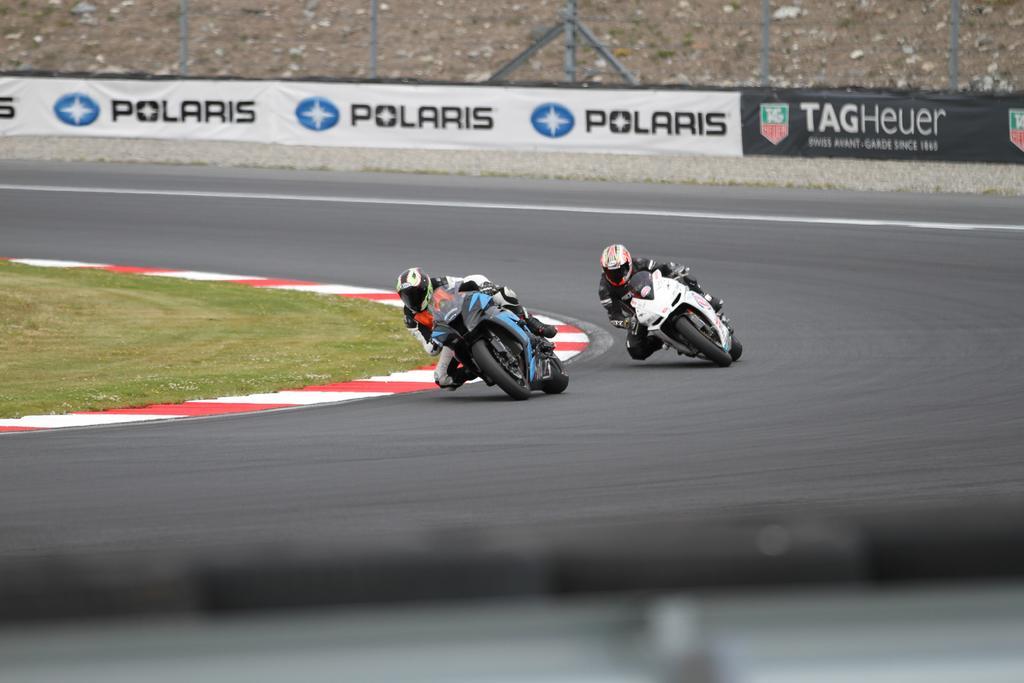Can you describe this image briefly? 2 persons are riding a bike and are racing with each other. Beside this person there is a grass. This 2 persons wore helmet. This is a road. The banner is around the road. 